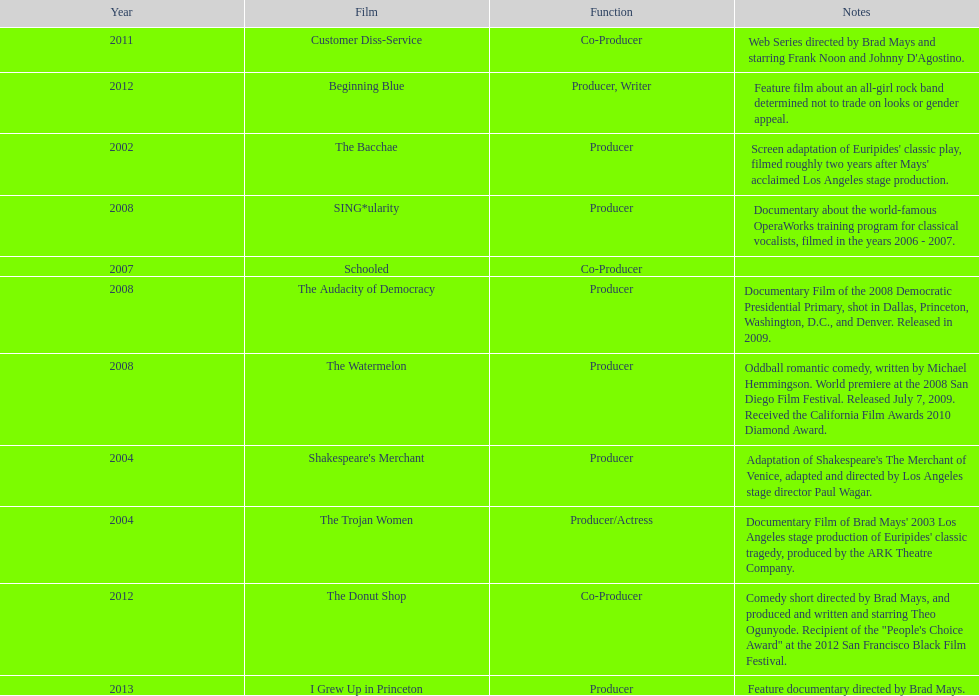Which film was before the audacity of democracy? The Watermelon. 